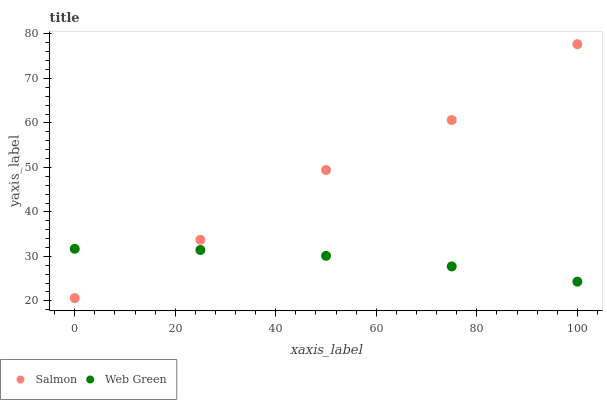Does Web Green have the minimum area under the curve?
Answer yes or no. Yes. Does Salmon have the maximum area under the curve?
Answer yes or no. Yes. Does Web Green have the maximum area under the curve?
Answer yes or no. No. Is Web Green the smoothest?
Answer yes or no. Yes. Is Salmon the roughest?
Answer yes or no. Yes. Is Web Green the roughest?
Answer yes or no. No. Does Salmon have the lowest value?
Answer yes or no. Yes. Does Web Green have the lowest value?
Answer yes or no. No. Does Salmon have the highest value?
Answer yes or no. Yes. Does Web Green have the highest value?
Answer yes or no. No. Does Salmon intersect Web Green?
Answer yes or no. Yes. Is Salmon less than Web Green?
Answer yes or no. No. Is Salmon greater than Web Green?
Answer yes or no. No. 